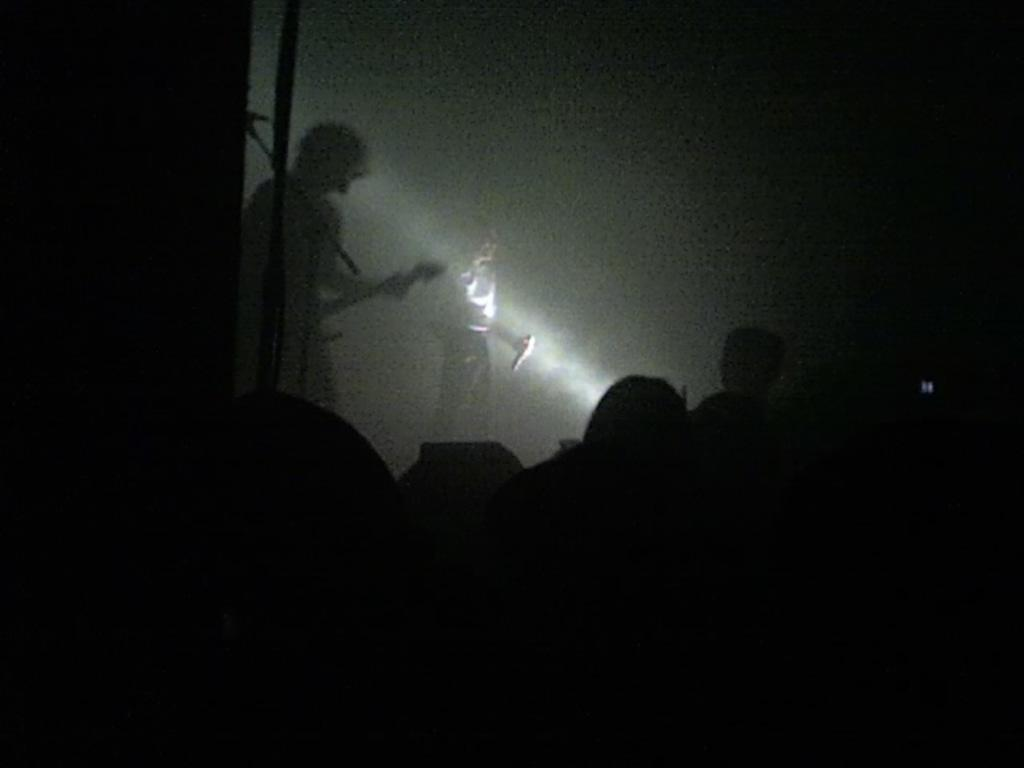How many people are in the image? There are people in the image, but the exact number is not specified. What activity is being performed by one of the people in the background? There is a person playing guitar in the background. What object is being held by a woman in the background? There is a woman holding a microphone in the background. How many cows can be seen grazing in the background of the image? There are no cows present in the image. What type of wood is being used to build the stage in the image? There is no stage or wood visible in the image. 